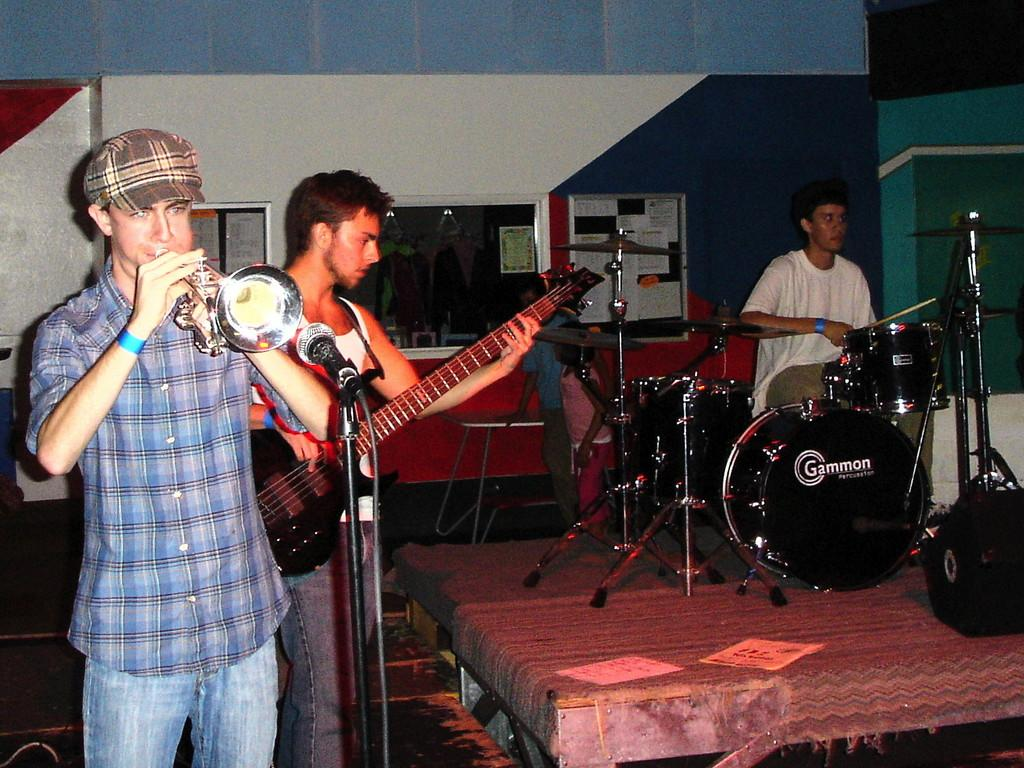How many people are in the image? There are five people in the image. What are the people in the image doing? The three persons are playing musical instruments, and the other two are likely part of the group or audience. What objects are present in the image that are related to sound or performance? There are microphones (mikes) in the image. What type of furniture can be seen in the image? There is a table in the image. What is visible in the background of the image? There is a wall in the background of the image. How much does the pig cost in the image? There is no pig present in the image, so it is not possible to determine its price. What is the fifth person doing in the image? There are only five people in the image, and their activities have already been described. There is no fifth person to discuss. 